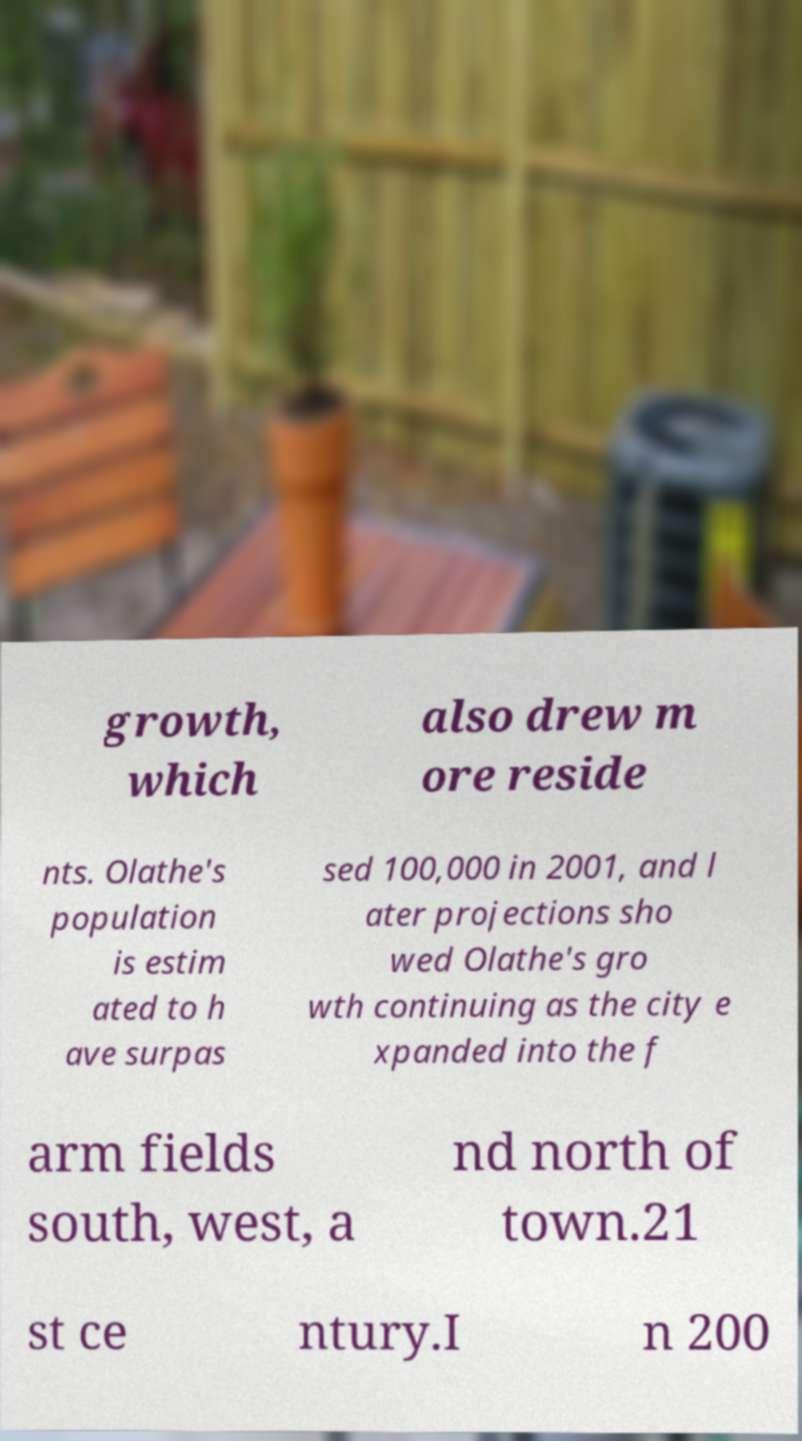Can you accurately transcribe the text from the provided image for me? growth, which also drew m ore reside nts. Olathe's population is estim ated to h ave surpas sed 100,000 in 2001, and l ater projections sho wed Olathe's gro wth continuing as the city e xpanded into the f arm fields south, west, a nd north of town.21 st ce ntury.I n 200 